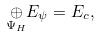Convert formula to latex. <formula><loc_0><loc_0><loc_500><loc_500>\underset { \Psi _ { H } } { \oplus } E _ { \psi } = E _ { c } ,</formula> 